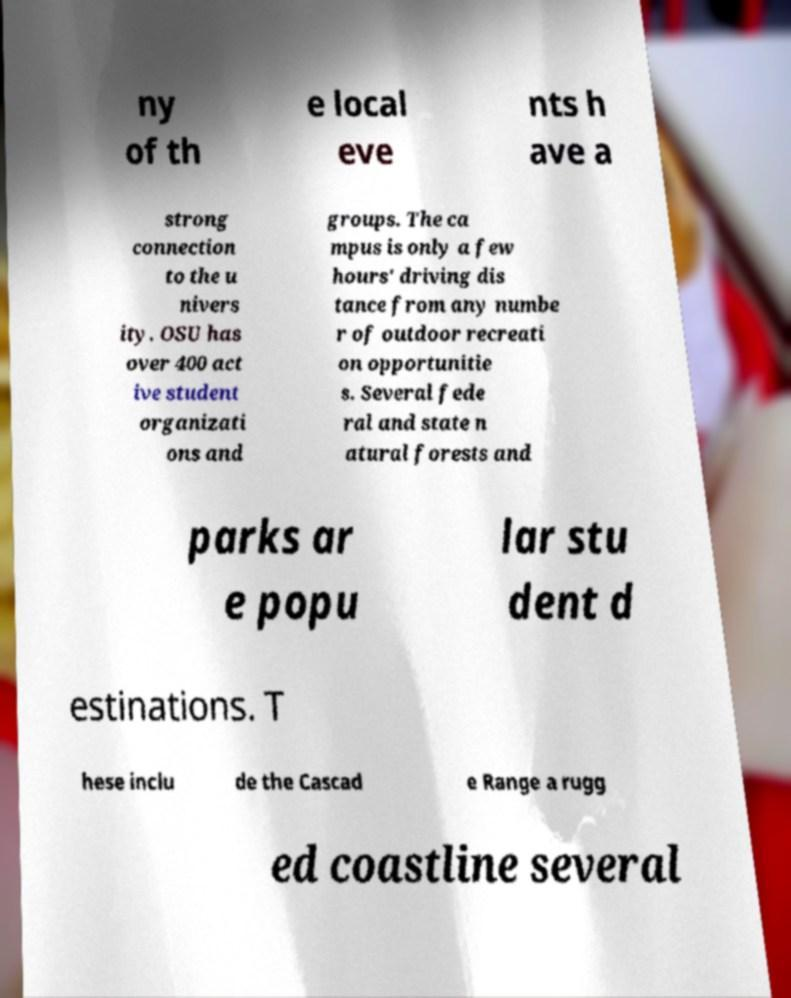Could you extract and type out the text from this image? ny of th e local eve nts h ave a strong connection to the u nivers ity. OSU has over 400 act ive student organizati ons and groups. The ca mpus is only a few hours' driving dis tance from any numbe r of outdoor recreati on opportunitie s. Several fede ral and state n atural forests and parks ar e popu lar stu dent d estinations. T hese inclu de the Cascad e Range a rugg ed coastline several 